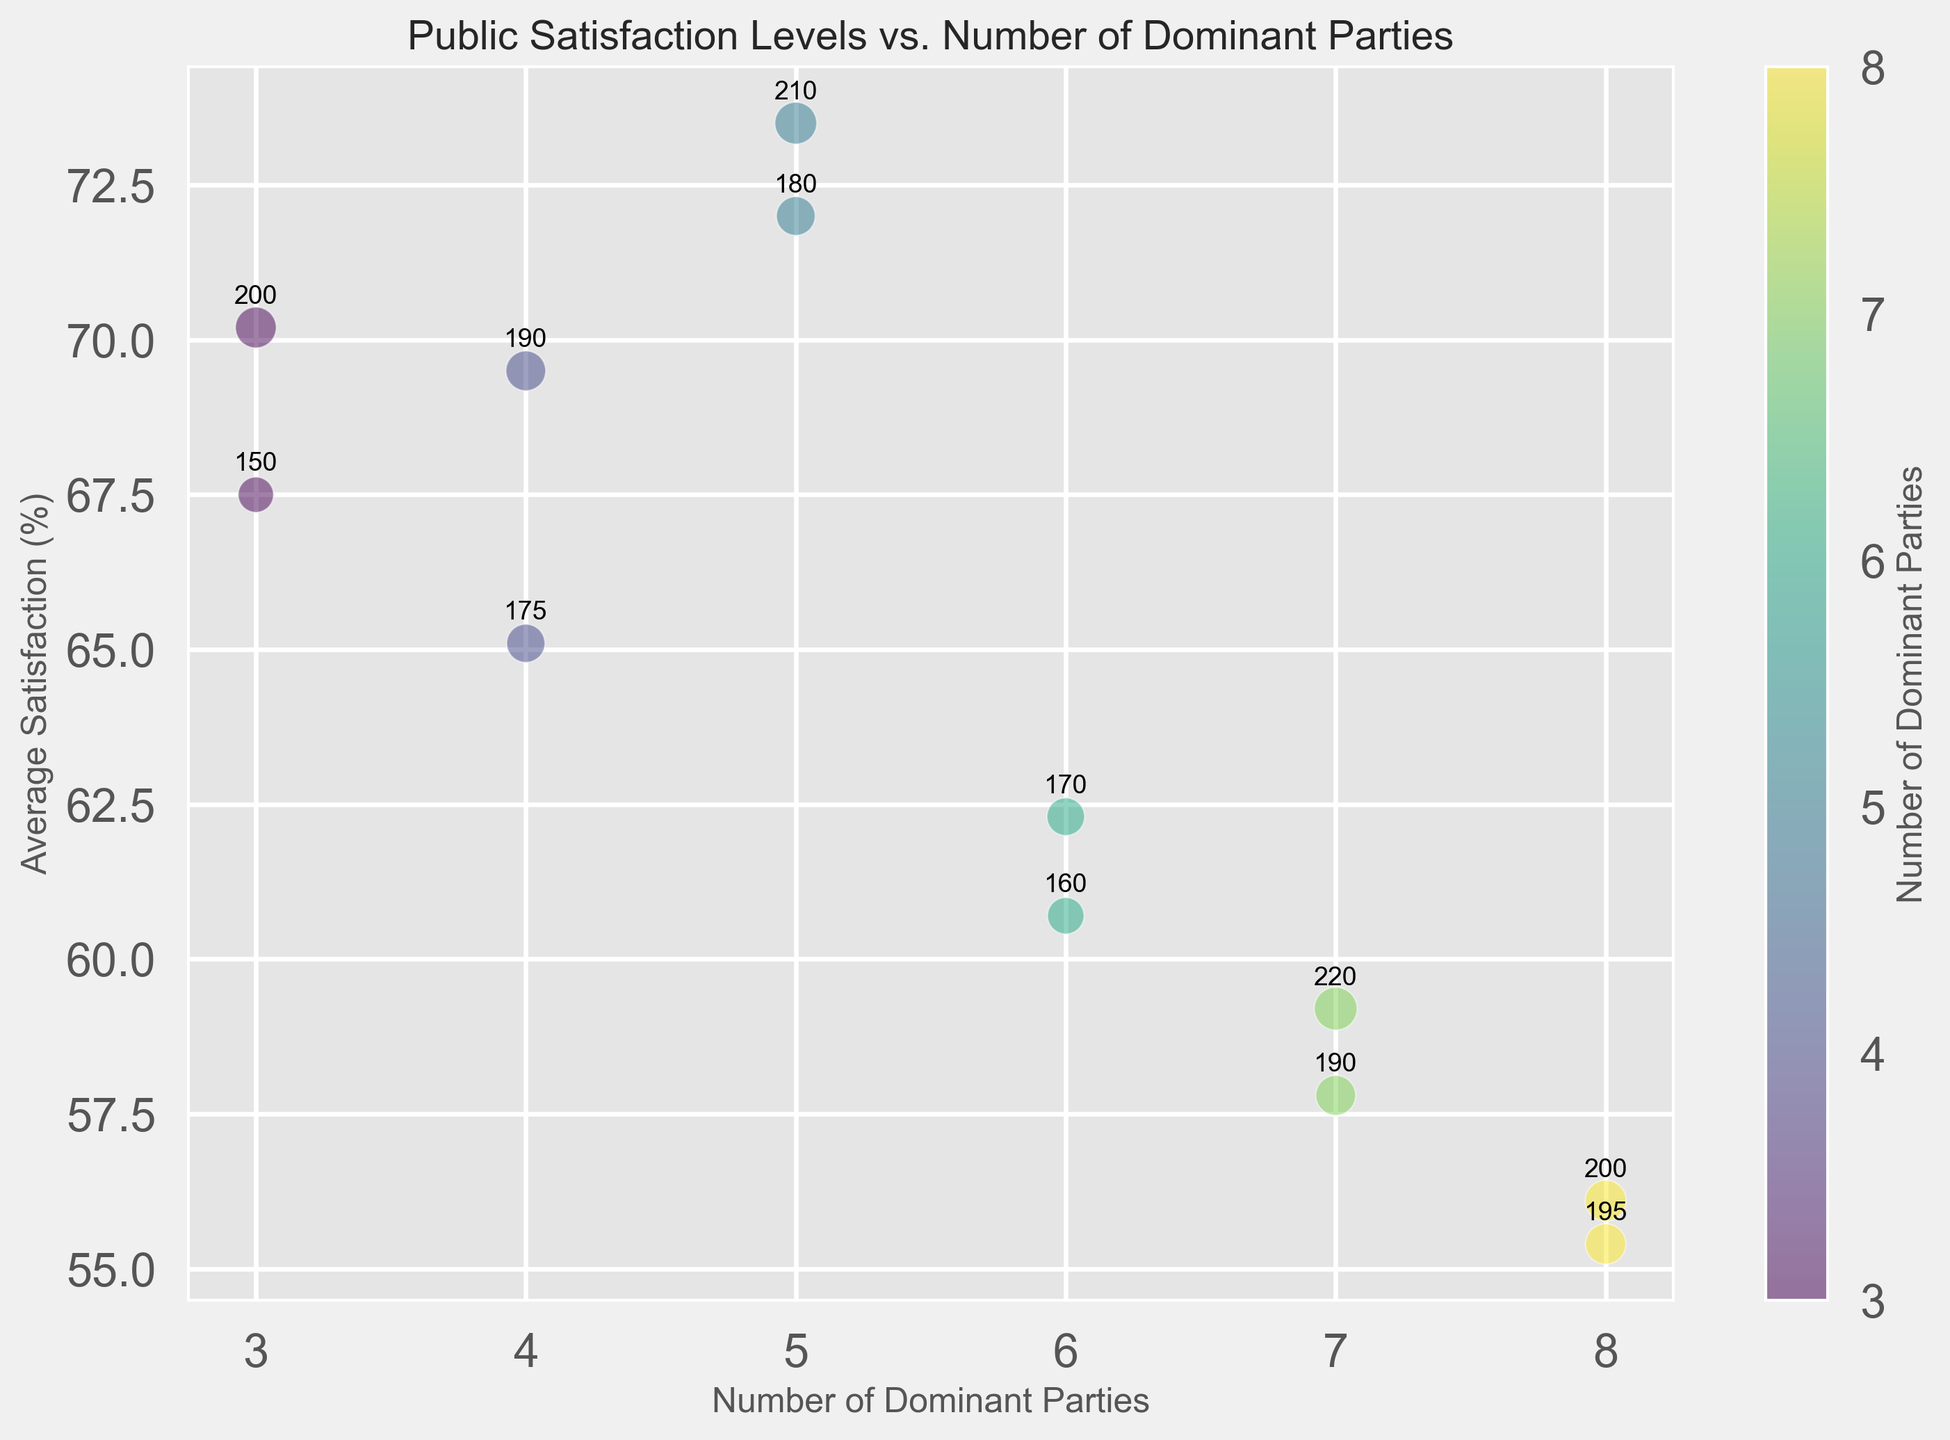What is the average satisfaction level for systems with 5 dominant parties? The visual shows two data points for 5 dominant parties with average satisfaction levels 72.0% and 73.5%. To find the average, sum these values (72.0 + 73.5 = 145.5) and divide by the number of points (145.5 / 2).
Answer: 72.75% Which number of dominant parties has the highest average satisfaction level? Anchor on the y-axis, locate the highest point among all bubbles. The highest point corresponds to 5 dominant parties with average satisfaction levels of 72.0% and 73.5%.
Answer: 5 Does the satisfaction level generally increase or decrease as the number of dominant parties increases from 3 to 8? Trace the average satisfaction level as you move from left to right on the x-axis. The satisfaction level generally decreases as we move from 3 to 8 dominant parties.
Answer: Decrease What is the difference in the average satisfaction between systems with 7 and 8 dominant parties? For 7 dominant parties, the average satisfaction levels are 57.8% and 59.2%. For 8 dominant parties, they are 55.4% and 56.1%. Calculate the average for each: (57.8 + 59.2)/2 = 58.5 and (55.4 + 56.1)/2 = 55.75. The difference is 58.5 - 55.75.
Answer: 2.75% What is the size of the largest bubble, and for which number of dominant parties is it? Identify the largest bubble visually, which appears clearer in terms of marker size. The largest bubble has 220 surveys for the 7 dominant parties category.
Answer: 220 for 7 dominant parties 